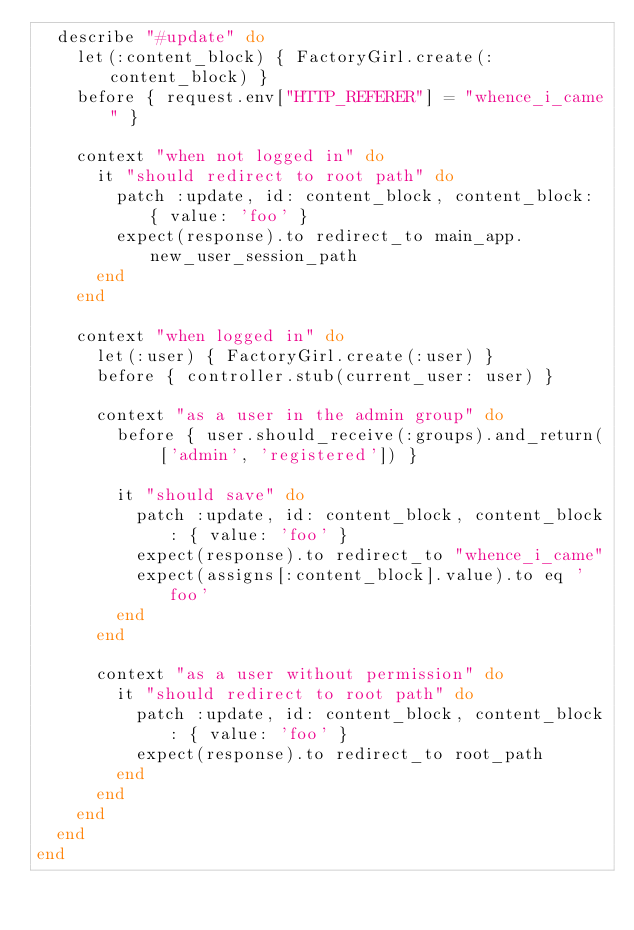Convert code to text. <code><loc_0><loc_0><loc_500><loc_500><_Ruby_>  describe "#update" do
    let(:content_block) { FactoryGirl.create(:content_block) }
    before { request.env["HTTP_REFERER"] = "whence_i_came" }

    context "when not logged in" do
      it "should redirect to root path" do
        patch :update, id: content_block, content_block: { value: 'foo' }
        expect(response).to redirect_to main_app.new_user_session_path
      end
    end

    context "when logged in" do
      let(:user) { FactoryGirl.create(:user) }
      before { controller.stub(current_user: user) }

      context "as a user in the admin group" do
        before { user.should_receive(:groups).and_return( ['admin', 'registered']) }

        it "should save" do
          patch :update, id: content_block, content_block: { value: 'foo' }
          expect(response).to redirect_to "whence_i_came"
          expect(assigns[:content_block].value).to eq 'foo'
        end
      end

      context "as a user without permission" do
        it "should redirect to root path" do
          patch :update, id: content_block, content_block: { value: 'foo' }
          expect(response).to redirect_to root_path
        end
      end
    end
  end
end
</code> 